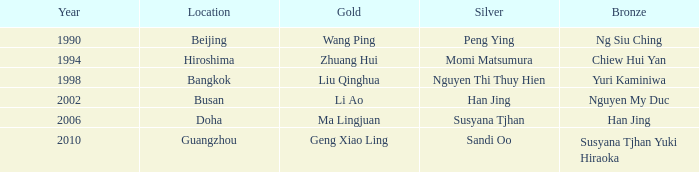What Silver has a Golf of Li AO? Han Jing. 